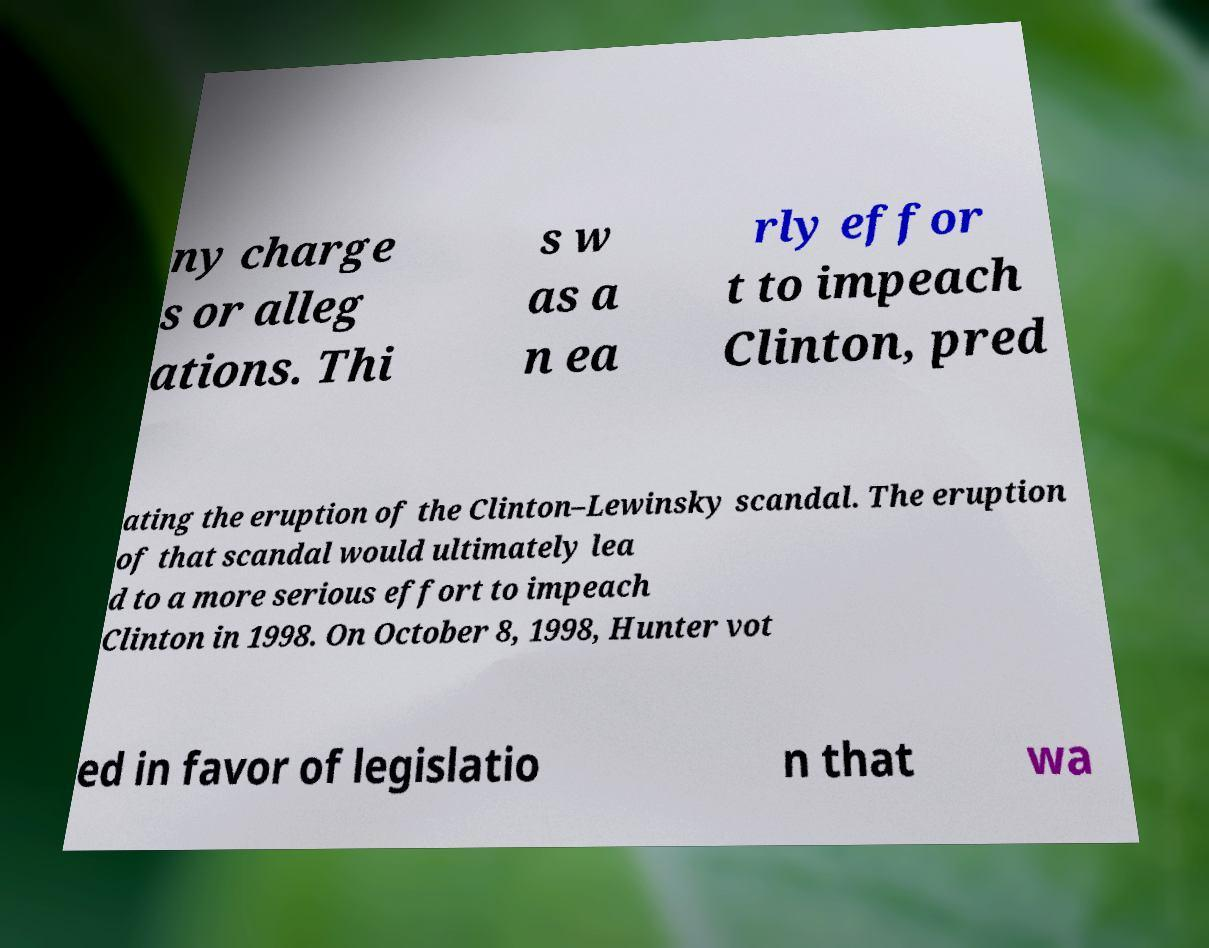Can you accurately transcribe the text from the provided image for me? ny charge s or alleg ations. Thi s w as a n ea rly effor t to impeach Clinton, pred ating the eruption of the Clinton–Lewinsky scandal. The eruption of that scandal would ultimately lea d to a more serious effort to impeach Clinton in 1998. On October 8, 1998, Hunter vot ed in favor of legislatio n that wa 